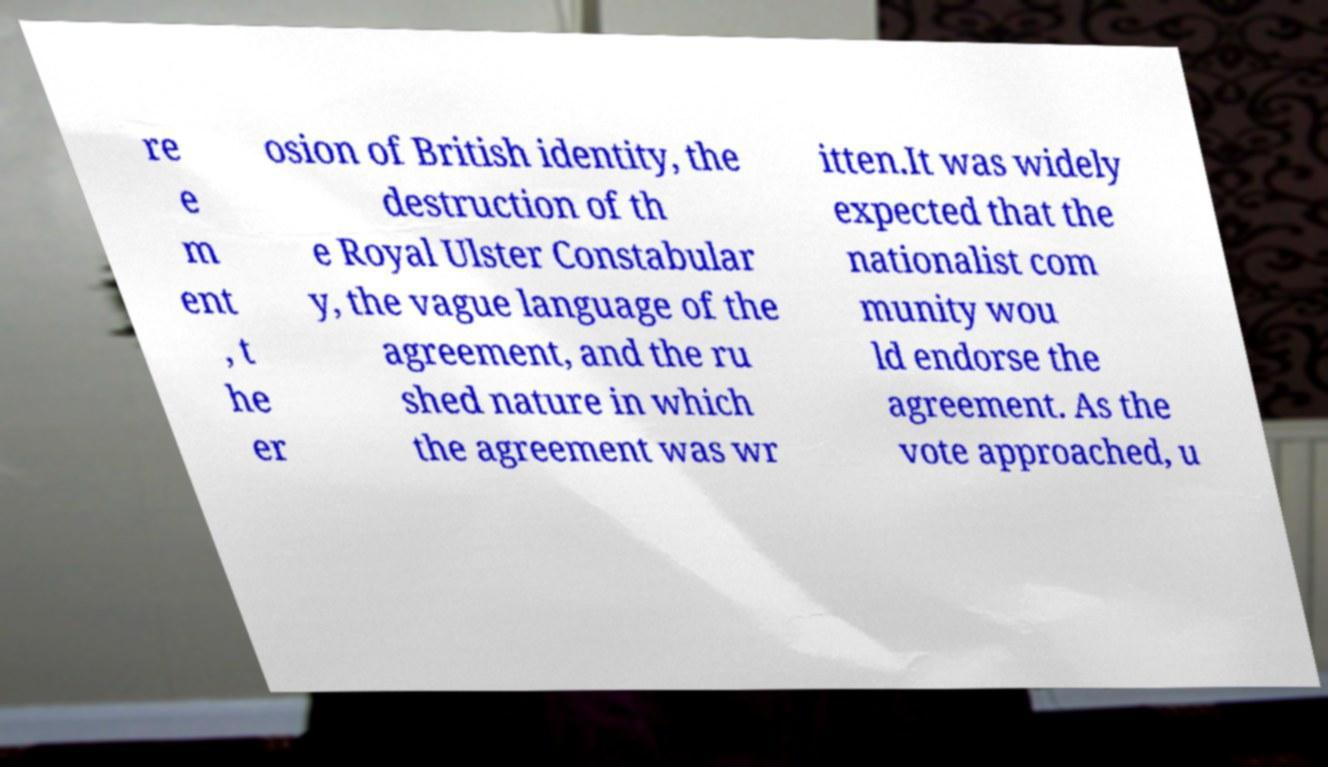Could you extract and type out the text from this image? re e m ent , t he er osion of British identity, the destruction of th e Royal Ulster Constabular y, the vague language of the agreement, and the ru shed nature in which the agreement was wr itten.It was widely expected that the nationalist com munity wou ld endorse the agreement. As the vote approached, u 